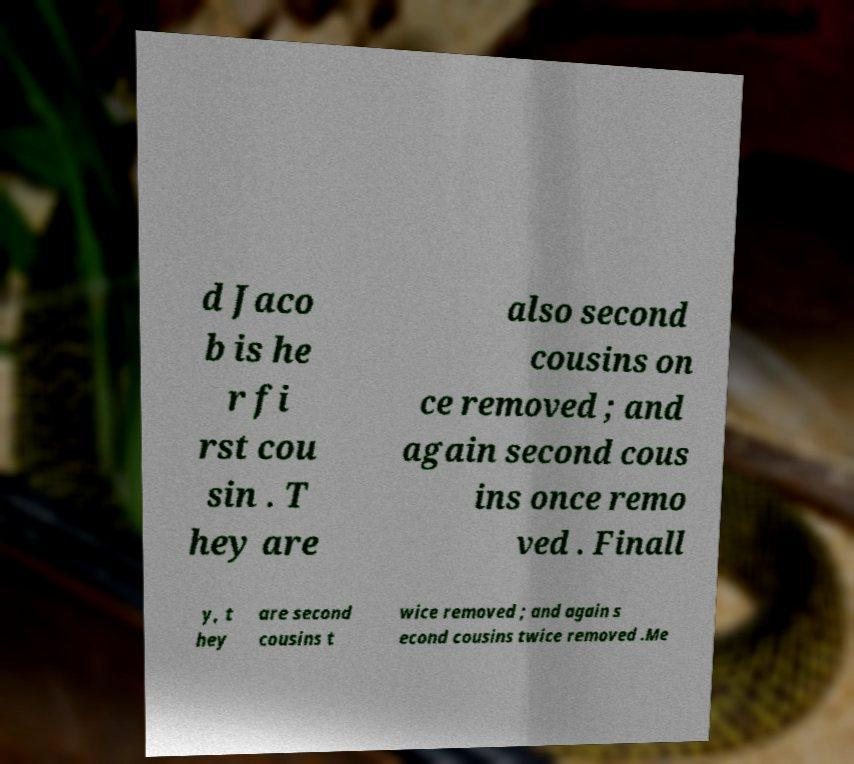There's text embedded in this image that I need extracted. Can you transcribe it verbatim? d Jaco b is he r fi rst cou sin . T hey are also second cousins on ce removed ; and again second cous ins once remo ved . Finall y, t hey are second cousins t wice removed ; and again s econd cousins twice removed .Me 